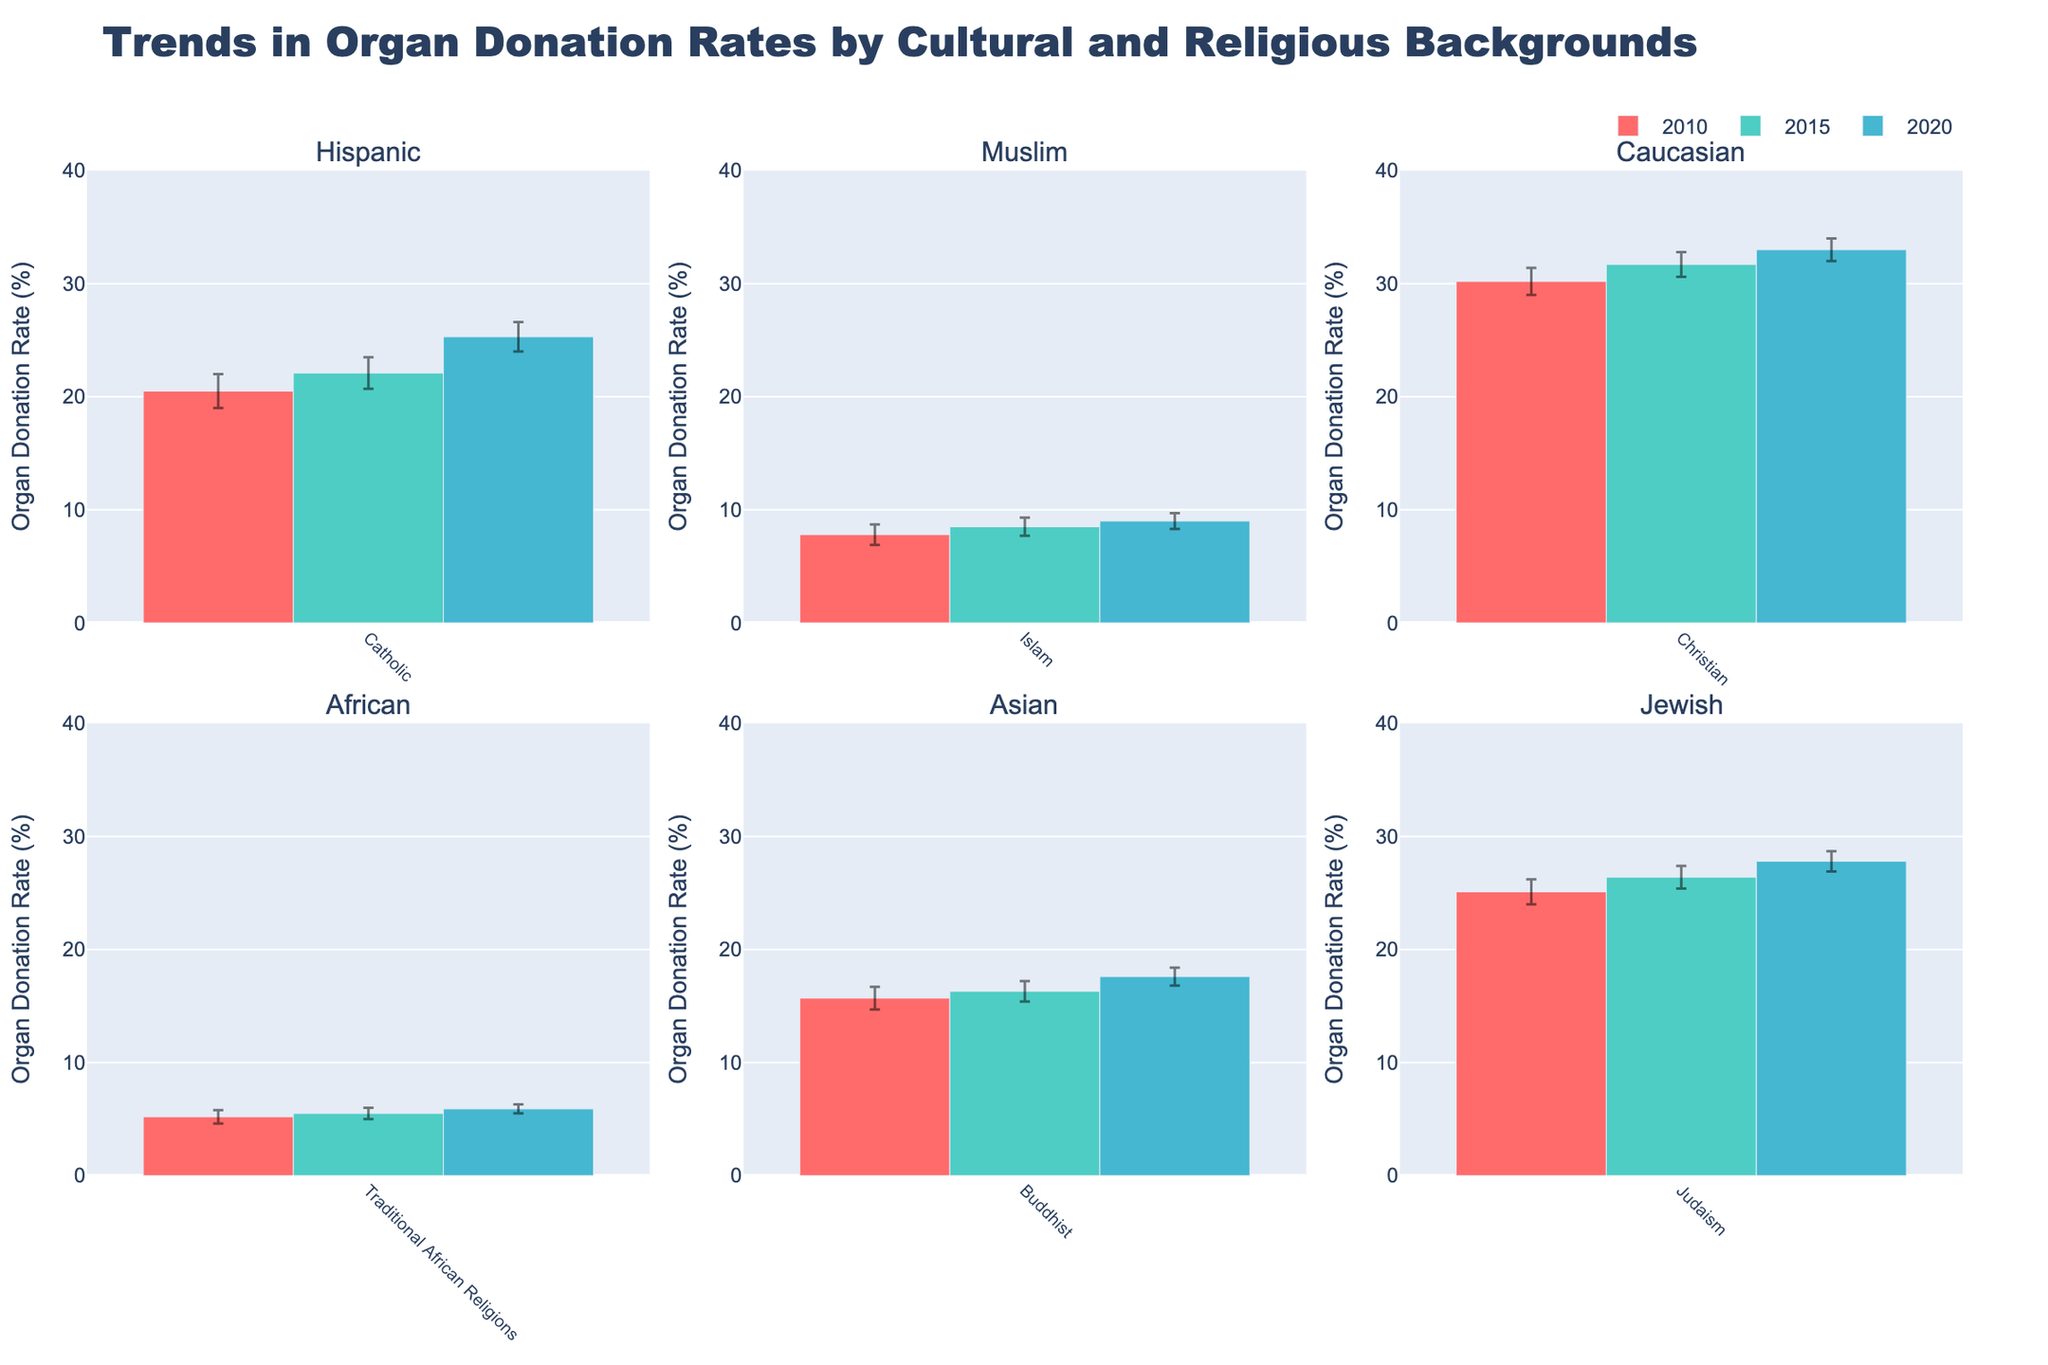What is the title of the figure? The title is clearly displayed at the top of the figure. It indicates the topic or focus of the visualized data.
Answer: Trends in Organ Donation Rates by Cultural and Religious Backgrounds Which cultural group shows the highest organ donation rate in 2020? From the bars shown for the year 2020 across different subplots, you need to identify which bar reaches the highest value.
Answer: Caucasian What is the organ donation rate for the Muslim cultural background in 2015? Locate the subplot for the Muslim cultural background and identify the bar representing the year 2015. The height of the bar indicates the rate.
Answer: 8.5% Which group has the lowest organ donation rate in 2010? Look at the 2010 bars across all subplots and identify the bar with the smallest height.
Answer: African How has the organ donation rate for the Hispanic cultural background changed from 2010 to 2020? Compare the heights of the bars for 2010 and 2020 in the Hispanic subplot. Calculate the difference.
Answer: Increased by 4.8% What is the difference between the organ donation rates for the Hispanic and Asian cultural backgrounds in 2020? Identify the 2020 rates for both Hispanic and Asian groups by comparing the bar heights in their respective subplots, and then calculate their difference.
Answer: 7.7% How many cultural backgrounds are represented in the figure? Count the number of subplots, each representing a different cultural background.
Answer: 6 For which cultural background does the organ donation rate show the least increase from 2010 to 2020? Look at the bars for 2010 and 2020 across all subplots and find the culture with the smallest difference in heights between these two years.
Answer: African Which year's bars are represented by the darkest color? Across the subplots' bars, observe the color intensity. The darkest color consistently represents the same year.
Answer: 2020 What are the error bars for the organ donation rates for the Jewish cultural background in 2020? Locate the subplot for the Jewish cultural background and the 2020 bar. The length of the error bars is often indicated.
Answer: ±0.9 